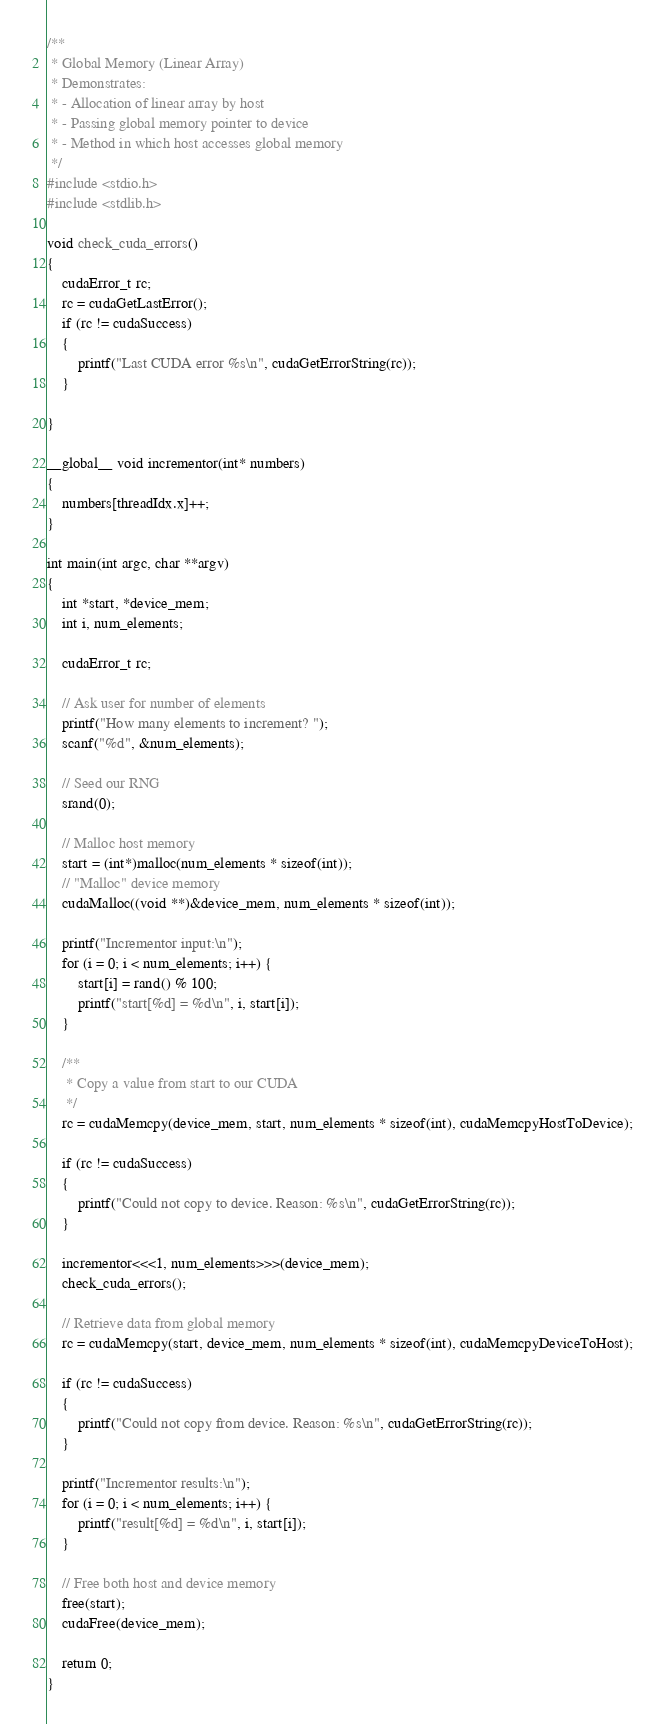<code> <loc_0><loc_0><loc_500><loc_500><_Cuda_>/**
 * Global Memory (Linear Array)
 * Demonstrates:
 * - Allocation of linear array by host
 * - Passing global memory pointer to device
 * - Method in which host accesses global memory
 */
#include <stdio.h>
#include <stdlib.h>

void check_cuda_errors()
{
    cudaError_t rc;
    rc = cudaGetLastError();
    if (rc != cudaSuccess)
    {
        printf("Last CUDA error %s\n", cudaGetErrorString(rc));
    }

}

__global__ void incrementor(int* numbers)
{
    numbers[threadIdx.x]++;
}

int main(int argc, char **argv)
{
    int *start, *device_mem;
    int i, num_elements;

    cudaError_t rc;

    // Ask user for number of elements
    printf("How many elements to increment? ");
    scanf("%d", &num_elements);

    // Seed our RNG
    srand(0);

    // Malloc host memory
    start = (int*)malloc(num_elements * sizeof(int));
    // "Malloc" device memory
    cudaMalloc((void **)&device_mem, num_elements * sizeof(int));

    printf("Incrementor input:\n");
    for (i = 0; i < num_elements; i++) {
        start[i] = rand() % 100;
        printf("start[%d] = %d\n", i, start[i]);
    }

    /**
     * Copy a value from start to our CUDA
     */
    rc = cudaMemcpy(device_mem, start, num_elements * sizeof(int), cudaMemcpyHostToDevice);

    if (rc != cudaSuccess)
    {
        printf("Could not copy to device. Reason: %s\n", cudaGetErrorString(rc));
    }

    incrementor<<<1, num_elements>>>(device_mem);
    check_cuda_errors();

    // Retrieve data from global memory
    rc = cudaMemcpy(start, device_mem, num_elements * sizeof(int), cudaMemcpyDeviceToHost);

    if (rc != cudaSuccess)
    {
        printf("Could not copy from device. Reason: %s\n", cudaGetErrorString(rc));
    }

    printf("Incrementor results:\n");
    for (i = 0; i < num_elements; i++) {
        printf("result[%d] = %d\n", i, start[i]);
    }

    // Free both host and device memory
    free(start);
    cudaFree(device_mem);

    return 0;
}
</code> 